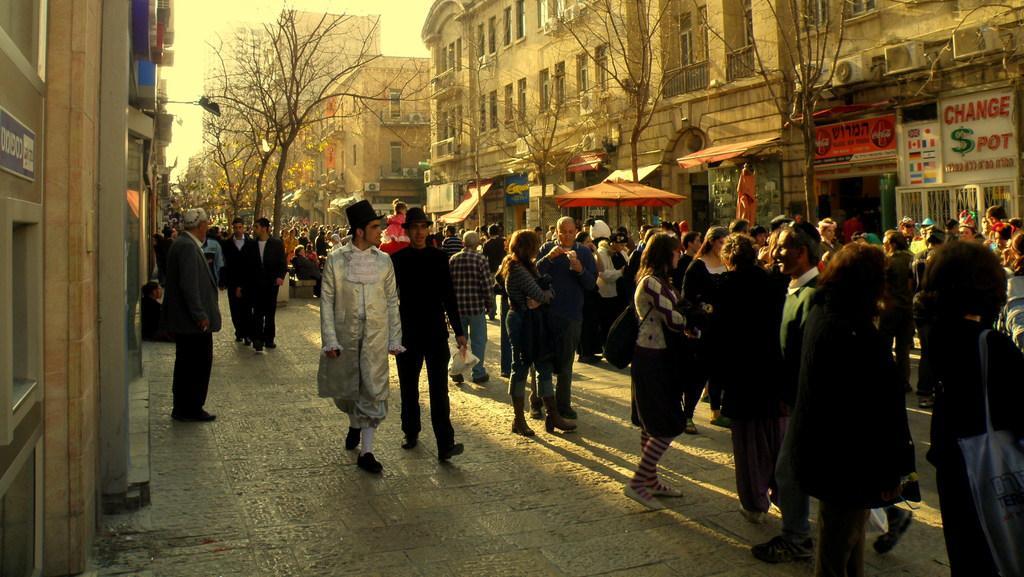Please provide a concise description of this image. In this image there is the sky truncated towards the top of the image, there are buildings, there are buildings truncated towards the top of the image, there is a building truncated towards the right of the image, there are building truncated towards the left of the image, there are building truncated towards the top of the image, there are boards on the buildings, there is text on the boards, there is an umbrella, there are trees truncated towards the top of the image, there is road truncated towards the bottom of the image, there are group of persons on the road, the persons are holding an object, the persons are wearing a bag, there are persons truncated towards the right of the image. 